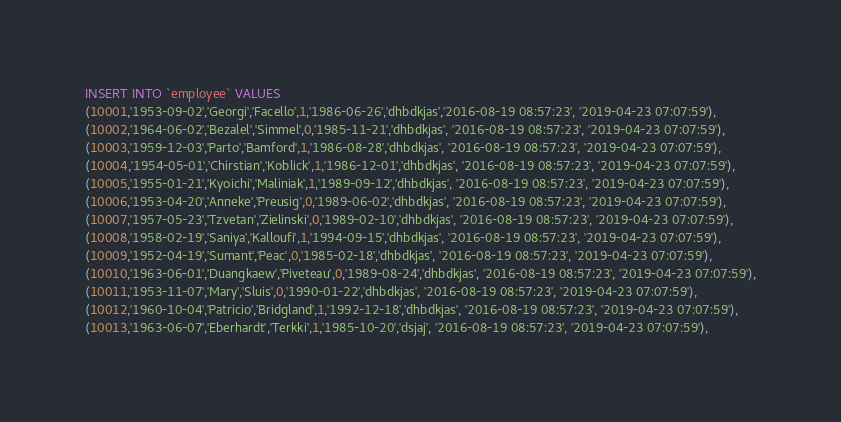Convert code to text. <code><loc_0><loc_0><loc_500><loc_500><_SQL_>INSERT INTO `employee` VALUES
(10001,'1953-09-02','Georgi','Facello',1,'1986-06-26','dhbdkjas','2016-08-19 08:57:23', '2019-04-23 07:07:59'),
(10002,'1964-06-02','Bezalel','Simmel',0,'1985-11-21','dhbdkjas', '2016-08-19 08:57:23', '2019-04-23 07:07:59'),
(10003,'1959-12-03','Parto','Bamford',1,'1986-08-28','dhbdkjas', '2016-08-19 08:57:23', '2019-04-23 07:07:59'),
(10004,'1954-05-01','Chirstian','Koblick',1,'1986-12-01','dhbdkjas', '2016-08-19 08:57:23', '2019-04-23 07:07:59'),
(10005,'1955-01-21','Kyoichi','Maliniak',1,'1989-09-12','dhbdkjas', '2016-08-19 08:57:23', '2019-04-23 07:07:59'),
(10006,'1953-04-20','Anneke','Preusig',0,'1989-06-02','dhbdkjas', '2016-08-19 08:57:23', '2019-04-23 07:07:59'),
(10007,'1957-05-23','Tzvetan','Zielinski',0,'1989-02-10','dhbdkjas', '2016-08-19 08:57:23', '2019-04-23 07:07:59'),
(10008,'1958-02-19','Saniya','Kalloufi',1,'1994-09-15','dhbdkjas', '2016-08-19 08:57:23', '2019-04-23 07:07:59'),
(10009,'1952-04-19','Sumant','Peac',0,'1985-02-18','dhbdkjas', '2016-08-19 08:57:23', '2019-04-23 07:07:59'),
(10010,'1963-06-01','Duangkaew','Piveteau',0,'1989-08-24','dhbdkjas', '2016-08-19 08:57:23', '2019-04-23 07:07:59'),
(10011,'1953-11-07','Mary','Sluis',0,'1990-01-22','dhbdkjas', '2016-08-19 08:57:23', '2019-04-23 07:07:59'),
(10012,'1960-10-04','Patricio','Bridgland',1,'1992-12-18','dhbdkjas', '2016-08-19 08:57:23', '2019-04-23 07:07:59'),
(10013,'1963-06-07','Eberhardt','Terkki',1,'1985-10-20','dsjaj', '2016-08-19 08:57:23', '2019-04-23 07:07:59'),</code> 